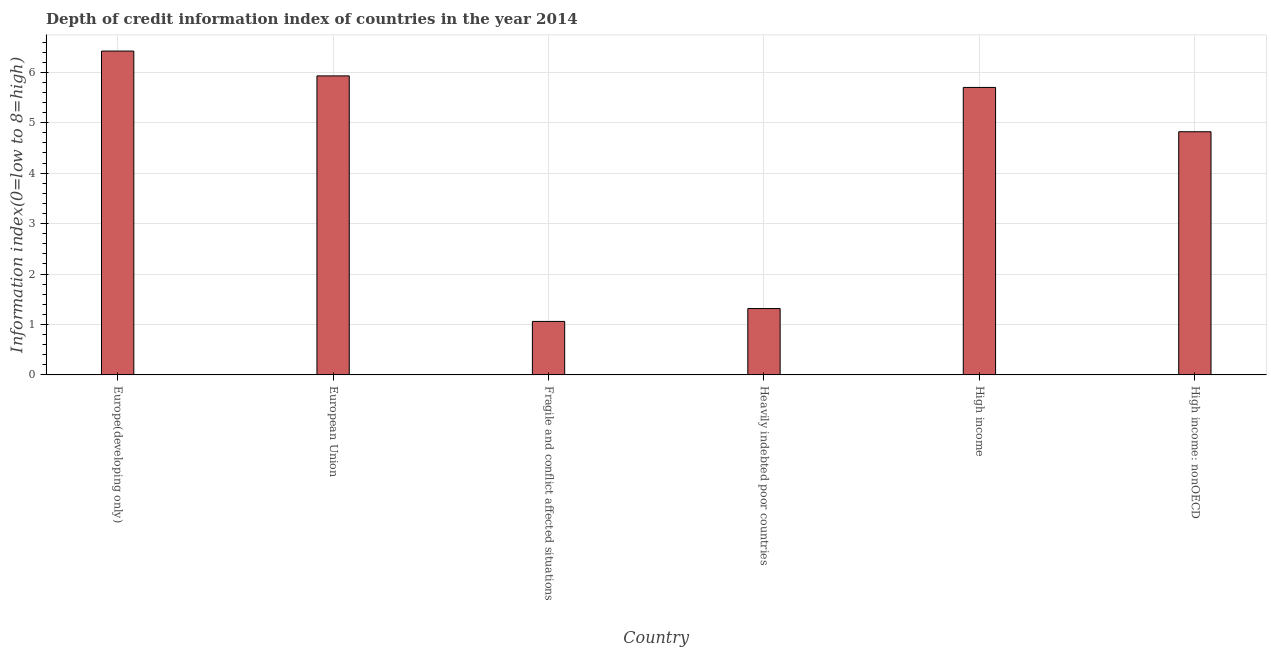What is the title of the graph?
Your answer should be compact. Depth of credit information index of countries in the year 2014. What is the label or title of the Y-axis?
Your answer should be very brief. Information index(0=low to 8=high). What is the depth of credit information index in Europe(developing only)?
Offer a very short reply. 6.42. Across all countries, what is the maximum depth of credit information index?
Offer a very short reply. 6.42. Across all countries, what is the minimum depth of credit information index?
Your response must be concise. 1.06. In which country was the depth of credit information index maximum?
Keep it short and to the point. Europe(developing only). In which country was the depth of credit information index minimum?
Make the answer very short. Fragile and conflict affected situations. What is the sum of the depth of credit information index?
Provide a short and direct response. 25.25. What is the average depth of credit information index per country?
Provide a short and direct response. 4.21. What is the median depth of credit information index?
Offer a terse response. 5.26. What is the ratio of the depth of credit information index in Fragile and conflict affected situations to that in High income: nonOECD?
Your answer should be compact. 0.22. Is the depth of credit information index in Fragile and conflict affected situations less than that in High income?
Provide a succinct answer. Yes. Is the difference between the depth of credit information index in Fragile and conflict affected situations and High income: nonOECD greater than the difference between any two countries?
Your answer should be compact. No. What is the difference between the highest and the second highest depth of credit information index?
Offer a very short reply. 0.49. What is the difference between the highest and the lowest depth of credit information index?
Your answer should be very brief. 5.36. In how many countries, is the depth of credit information index greater than the average depth of credit information index taken over all countries?
Offer a very short reply. 4. How many bars are there?
Ensure brevity in your answer.  6. Are all the bars in the graph horizontal?
Make the answer very short. No. What is the Information index(0=low to 8=high) of Europe(developing only)?
Keep it short and to the point. 6.42. What is the Information index(0=low to 8=high) in European Union?
Provide a short and direct response. 5.93. What is the Information index(0=low to 8=high) of Fragile and conflict affected situations?
Keep it short and to the point. 1.06. What is the Information index(0=low to 8=high) of Heavily indebted poor countries?
Your response must be concise. 1.32. What is the Information index(0=low to 8=high) of High income: nonOECD?
Keep it short and to the point. 4.82. What is the difference between the Information index(0=low to 8=high) in Europe(developing only) and European Union?
Keep it short and to the point. 0.49. What is the difference between the Information index(0=low to 8=high) in Europe(developing only) and Fragile and conflict affected situations?
Your answer should be compact. 5.36. What is the difference between the Information index(0=low to 8=high) in Europe(developing only) and Heavily indebted poor countries?
Ensure brevity in your answer.  5.11. What is the difference between the Information index(0=low to 8=high) in Europe(developing only) and High income?
Offer a very short reply. 0.72. What is the difference between the Information index(0=low to 8=high) in Europe(developing only) and High income: nonOECD?
Provide a short and direct response. 1.6. What is the difference between the Information index(0=low to 8=high) in European Union and Fragile and conflict affected situations?
Your response must be concise. 4.87. What is the difference between the Information index(0=low to 8=high) in European Union and Heavily indebted poor countries?
Ensure brevity in your answer.  4.61. What is the difference between the Information index(0=low to 8=high) in European Union and High income?
Ensure brevity in your answer.  0.23. What is the difference between the Information index(0=low to 8=high) in European Union and High income: nonOECD?
Provide a short and direct response. 1.11. What is the difference between the Information index(0=low to 8=high) in Fragile and conflict affected situations and Heavily indebted poor countries?
Your answer should be compact. -0.26. What is the difference between the Information index(0=low to 8=high) in Fragile and conflict affected situations and High income?
Offer a very short reply. -4.64. What is the difference between the Information index(0=low to 8=high) in Fragile and conflict affected situations and High income: nonOECD?
Offer a terse response. -3.76. What is the difference between the Information index(0=low to 8=high) in Heavily indebted poor countries and High income?
Ensure brevity in your answer.  -4.38. What is the difference between the Information index(0=low to 8=high) in Heavily indebted poor countries and High income: nonOECD?
Give a very brief answer. -3.51. What is the difference between the Information index(0=low to 8=high) in High income and High income: nonOECD?
Your answer should be very brief. 0.88. What is the ratio of the Information index(0=low to 8=high) in Europe(developing only) to that in European Union?
Ensure brevity in your answer.  1.08. What is the ratio of the Information index(0=low to 8=high) in Europe(developing only) to that in Fragile and conflict affected situations?
Keep it short and to the point. 6.05. What is the ratio of the Information index(0=low to 8=high) in Europe(developing only) to that in Heavily indebted poor countries?
Your response must be concise. 4.88. What is the ratio of the Information index(0=low to 8=high) in Europe(developing only) to that in High income?
Make the answer very short. 1.13. What is the ratio of the Information index(0=low to 8=high) in Europe(developing only) to that in High income: nonOECD?
Make the answer very short. 1.33. What is the ratio of the Information index(0=low to 8=high) in European Union to that in Fragile and conflict affected situations?
Your response must be concise. 5.59. What is the ratio of the Information index(0=low to 8=high) in European Union to that in Heavily indebted poor countries?
Provide a succinct answer. 4.51. What is the ratio of the Information index(0=low to 8=high) in European Union to that in High income: nonOECD?
Your answer should be compact. 1.23. What is the ratio of the Information index(0=low to 8=high) in Fragile and conflict affected situations to that in Heavily indebted poor countries?
Your answer should be compact. 0.81. What is the ratio of the Information index(0=low to 8=high) in Fragile and conflict affected situations to that in High income?
Keep it short and to the point. 0.19. What is the ratio of the Information index(0=low to 8=high) in Fragile and conflict affected situations to that in High income: nonOECD?
Your response must be concise. 0.22. What is the ratio of the Information index(0=low to 8=high) in Heavily indebted poor countries to that in High income?
Your answer should be compact. 0.23. What is the ratio of the Information index(0=low to 8=high) in Heavily indebted poor countries to that in High income: nonOECD?
Make the answer very short. 0.27. What is the ratio of the Information index(0=low to 8=high) in High income to that in High income: nonOECD?
Your response must be concise. 1.18. 